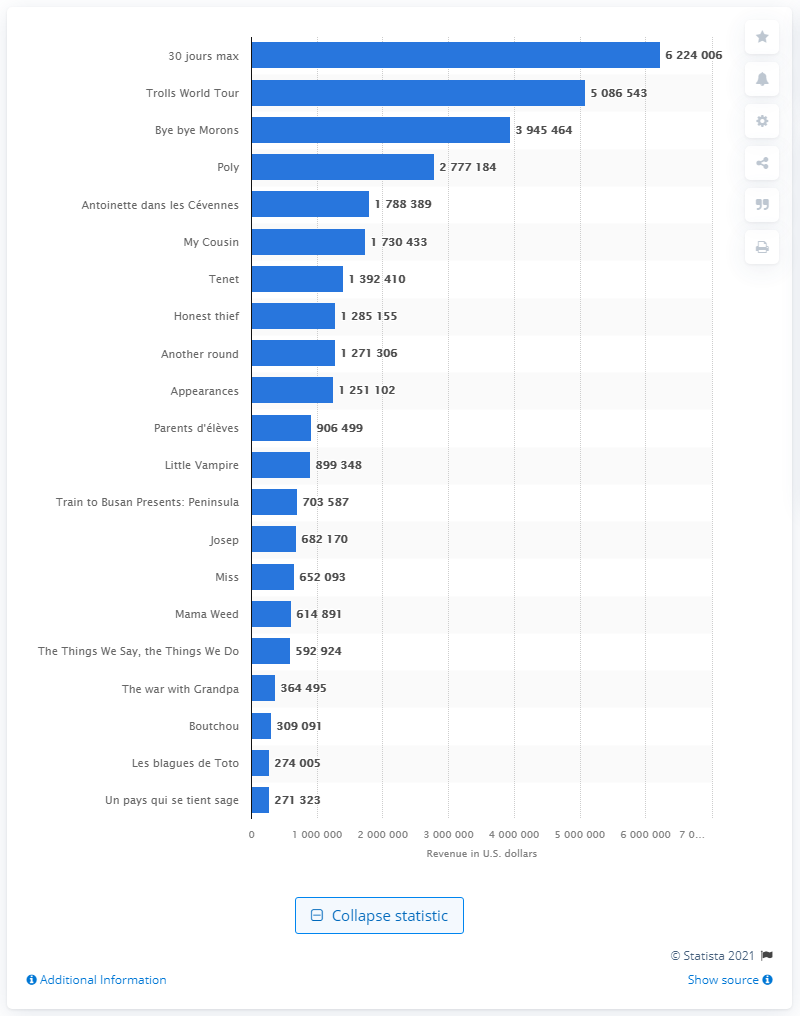Identify some key points in this picture. The amount earned by '30 Jours Max' is 6224006... 